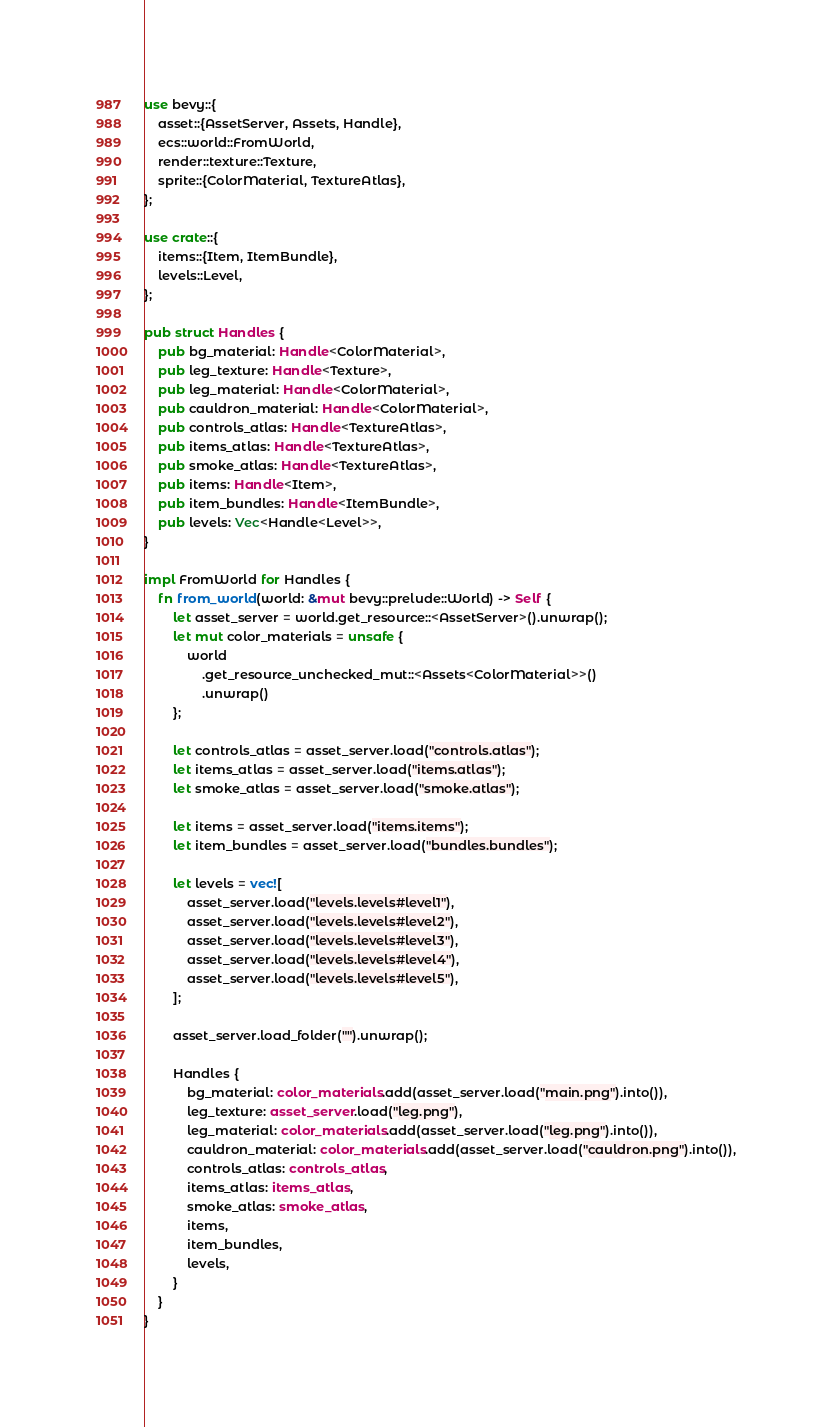<code> <loc_0><loc_0><loc_500><loc_500><_Rust_>use bevy::{
    asset::{AssetServer, Assets, Handle},
    ecs::world::FromWorld,
    render::texture::Texture,
    sprite::{ColorMaterial, TextureAtlas},
};

use crate::{
    items::{Item, ItemBundle},
    levels::Level,
};

pub struct Handles {
    pub bg_material: Handle<ColorMaterial>,
    pub leg_texture: Handle<Texture>,
    pub leg_material: Handle<ColorMaterial>,
    pub cauldron_material: Handle<ColorMaterial>,
    pub controls_atlas: Handle<TextureAtlas>,
    pub items_atlas: Handle<TextureAtlas>,
    pub smoke_atlas: Handle<TextureAtlas>,
    pub items: Handle<Item>,
    pub item_bundles: Handle<ItemBundle>,
    pub levels: Vec<Handle<Level>>,
}

impl FromWorld for Handles {
    fn from_world(world: &mut bevy::prelude::World) -> Self {
        let asset_server = world.get_resource::<AssetServer>().unwrap();
        let mut color_materials = unsafe {
            world
                .get_resource_unchecked_mut::<Assets<ColorMaterial>>()
                .unwrap()
        };

        let controls_atlas = asset_server.load("controls.atlas");
        let items_atlas = asset_server.load("items.atlas");
        let smoke_atlas = asset_server.load("smoke.atlas");

        let items = asset_server.load("items.items");
        let item_bundles = asset_server.load("bundles.bundles");

        let levels = vec![
            asset_server.load("levels.levels#level1"),
            asset_server.load("levels.levels#level2"),
            asset_server.load("levels.levels#level3"),
            asset_server.load("levels.levels#level4"),
            asset_server.load("levels.levels#level5"),
        ];

        asset_server.load_folder("").unwrap();

        Handles {
            bg_material: color_materials.add(asset_server.load("main.png").into()),
            leg_texture: asset_server.load("leg.png"),
            leg_material: color_materials.add(asset_server.load("leg.png").into()),
            cauldron_material: color_materials.add(asset_server.load("cauldron.png").into()),
            controls_atlas: controls_atlas,
            items_atlas: items_atlas,
            smoke_atlas: smoke_atlas,
            items,
            item_bundles,
            levels,
        }
    }
}
</code> 